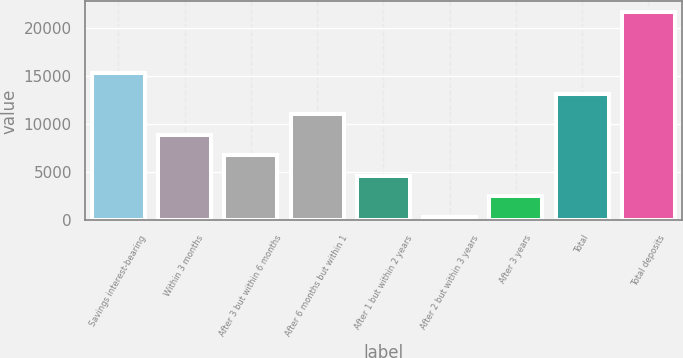Convert chart to OTSL. <chart><loc_0><loc_0><loc_500><loc_500><bar_chart><fcel>Savings interest-bearing<fcel>Within 3 months<fcel>After 3 but within 6 months<fcel>After 6 months but within 1<fcel>After 1 but within 2 years<fcel>After 2 but within 3 years<fcel>After 3 years<fcel>Total<fcel>Total deposits<nl><fcel>15339.1<fcel>8927.72<fcel>6790.59<fcel>11064.9<fcel>4653.46<fcel>379.2<fcel>2516.33<fcel>13202<fcel>21750.5<nl></chart> 